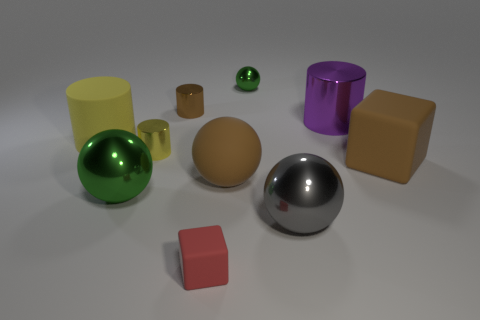There is a large object that is both to the right of the large brown matte sphere and in front of the big block; what shape is it?
Your answer should be very brief. Sphere. What color is the block that is behind the red object?
Offer a very short reply. Brown. Are there any other things of the same color as the small rubber block?
Keep it short and to the point. No. Do the red rubber object and the brown cylinder have the same size?
Your answer should be very brief. Yes. How big is the metal thing that is in front of the purple metal thing and behind the big green shiny object?
Your answer should be very brief. Small. What number of purple objects have the same material as the tiny brown cylinder?
Provide a short and direct response. 1. The matte object that is the same color as the rubber ball is what shape?
Your answer should be compact. Cube. The large rubber cylinder has what color?
Provide a short and direct response. Yellow. There is a green metallic thing left of the red matte block; is its shape the same as the gray metallic object?
Your answer should be compact. Yes. How many things are large cylinders right of the small green thing or small gray things?
Offer a very short reply. 1. 